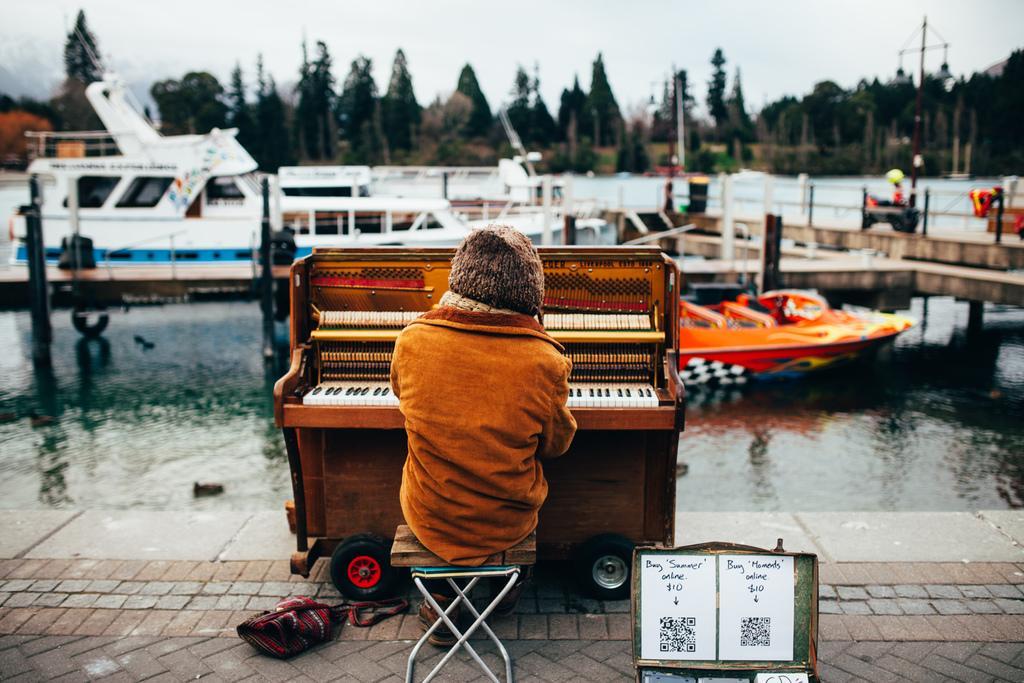How would you summarize this image in a sentence or two? In this image I can see a man is sitting on a stool next to a musical instrument. In the background I can see water, few boats and number of trees. 